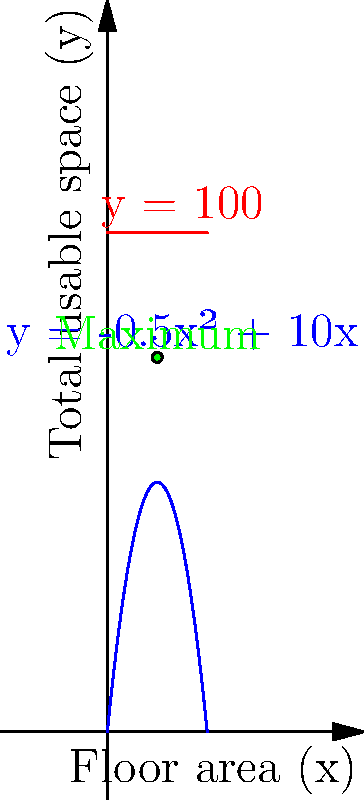As a construction project manager, you're tasked with optimizing the floor space efficiency in a multi-story building. The total usable space (y) in square meters is given by the function $y = -0.5x^2 + 10x$, where x is the floor area of each story in square meters. The building code restricts the total usable space to a maximum of 100 square meters. What floor area should each story have to maximize the total usable space while complying with the building code? To solve this problem, we'll follow these steps:

1) The total usable space is given by the quadratic function: $y = -0.5x^2 + 10x$

2) We need to find the maximum of this function, subject to the constraint $y \leq 100$.

3) To find the maximum of the unconstrained function, we differentiate y with respect to x and set it to zero:

   $\frac{dy}{dx} = -x + 10 = 0$
   $x = 10$

4) Let's check if this satisfies our constraint:

   $y = -0.5(10)^2 + 10(10) = -50 + 100 = 50$

   This is less than 100, so it satisfies the constraint.

5) The vertex of the parabola $(10, 50)$ represents the maximum point of the function.

6) Therefore, the floor area that maximizes the total usable space while complying with the building code is 10 square meters per story.
Answer: 10 square meters 